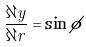<formula> <loc_0><loc_0><loc_500><loc_500>\frac { \partial y } { \partial r } = \sin \phi</formula> 